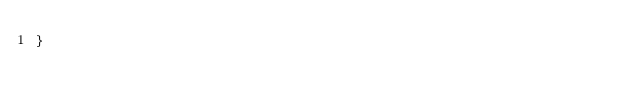<code> <loc_0><loc_0><loc_500><loc_500><_Go_>}
</code> 